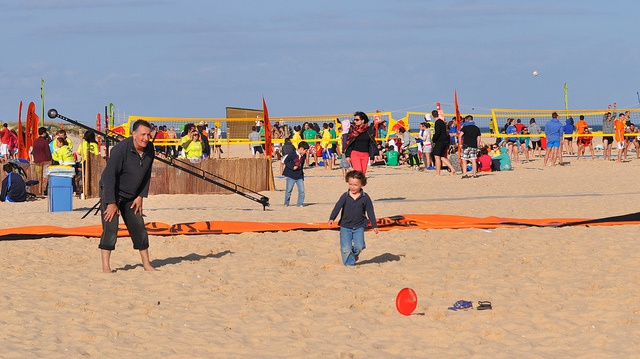Describe the objects in this image and their specific colors. I can see people in darkgray, black, tan, and brown tones, people in darkgray, black, salmon, brown, and maroon tones, people in darkgray, black, and gray tones, people in darkgray, black, salmon, maroon, and brown tones, and people in darkgray, black, and gray tones in this image. 